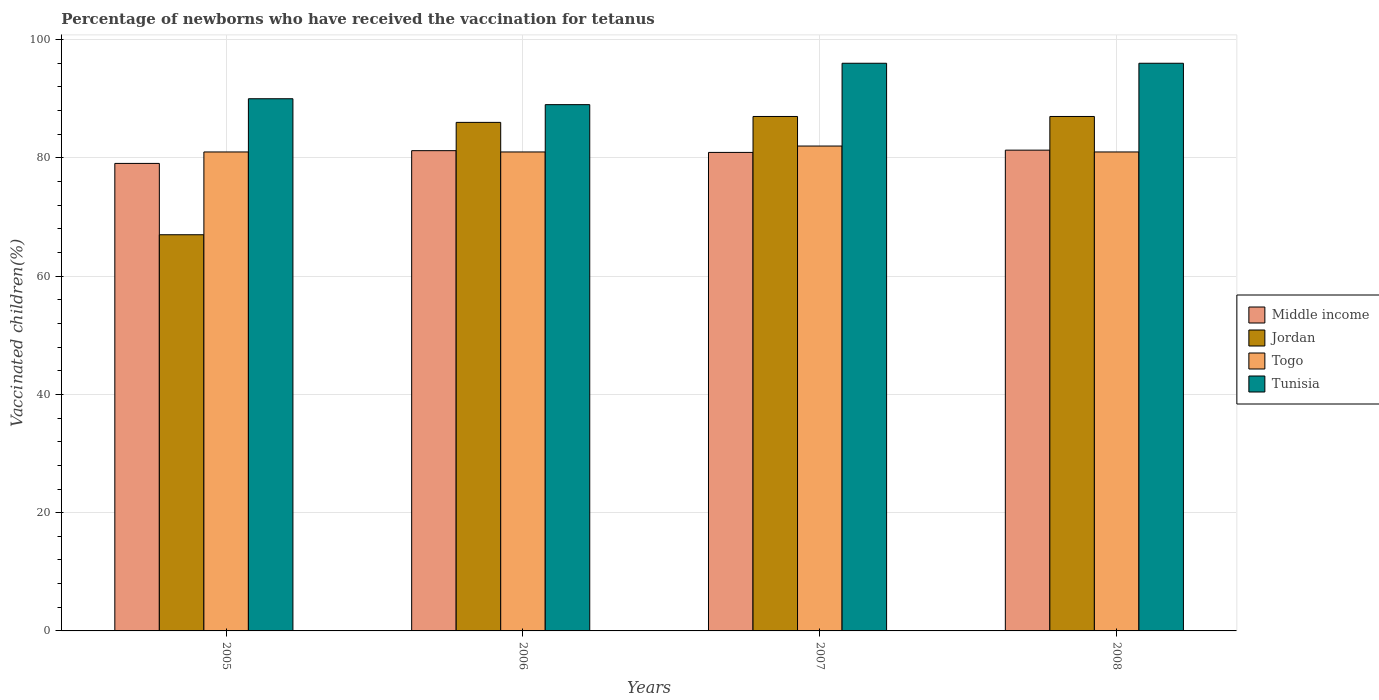How many bars are there on the 2nd tick from the left?
Provide a succinct answer. 4. How many bars are there on the 2nd tick from the right?
Offer a very short reply. 4. In how many cases, is the number of bars for a given year not equal to the number of legend labels?
Keep it short and to the point. 0. Across all years, what is the maximum percentage of vaccinated children in Jordan?
Your answer should be compact. 87. Across all years, what is the minimum percentage of vaccinated children in Togo?
Offer a very short reply. 81. In which year was the percentage of vaccinated children in Tunisia maximum?
Offer a very short reply. 2007. What is the total percentage of vaccinated children in Tunisia in the graph?
Keep it short and to the point. 371. What is the difference between the percentage of vaccinated children in Tunisia in 2008 and the percentage of vaccinated children in Middle income in 2007?
Offer a very short reply. 15.08. What is the average percentage of vaccinated children in Middle income per year?
Your answer should be very brief. 80.63. In the year 2005, what is the difference between the percentage of vaccinated children in Togo and percentage of vaccinated children in Tunisia?
Your response must be concise. -9. In how many years, is the percentage of vaccinated children in Jordan greater than 20 %?
Keep it short and to the point. 4. Is the percentage of vaccinated children in Jordan in 2006 less than that in 2008?
Provide a succinct answer. Yes. Is the difference between the percentage of vaccinated children in Togo in 2005 and 2007 greater than the difference between the percentage of vaccinated children in Tunisia in 2005 and 2007?
Offer a terse response. Yes. What is the difference between the highest and the second highest percentage of vaccinated children in Jordan?
Your answer should be compact. 0. What is the difference between the highest and the lowest percentage of vaccinated children in Middle income?
Your answer should be very brief. 2.24. What does the 2nd bar from the left in 2007 represents?
Provide a succinct answer. Jordan. Is it the case that in every year, the sum of the percentage of vaccinated children in Togo and percentage of vaccinated children in Middle income is greater than the percentage of vaccinated children in Tunisia?
Provide a short and direct response. Yes. Are all the bars in the graph horizontal?
Give a very brief answer. No. How many years are there in the graph?
Your answer should be very brief. 4. Does the graph contain any zero values?
Ensure brevity in your answer.  No. What is the title of the graph?
Your answer should be compact. Percentage of newborns who have received the vaccination for tetanus. What is the label or title of the Y-axis?
Your answer should be very brief. Vaccinated children(%). What is the Vaccinated children(%) in Middle income in 2005?
Your answer should be very brief. 79.06. What is the Vaccinated children(%) in Jordan in 2005?
Your answer should be very brief. 67. What is the Vaccinated children(%) of Middle income in 2006?
Your answer should be very brief. 81.22. What is the Vaccinated children(%) of Tunisia in 2006?
Give a very brief answer. 89. What is the Vaccinated children(%) in Middle income in 2007?
Your response must be concise. 80.92. What is the Vaccinated children(%) of Tunisia in 2007?
Offer a very short reply. 96. What is the Vaccinated children(%) of Middle income in 2008?
Give a very brief answer. 81.3. What is the Vaccinated children(%) in Jordan in 2008?
Keep it short and to the point. 87. What is the Vaccinated children(%) of Tunisia in 2008?
Keep it short and to the point. 96. Across all years, what is the maximum Vaccinated children(%) of Middle income?
Offer a terse response. 81.3. Across all years, what is the maximum Vaccinated children(%) of Tunisia?
Make the answer very short. 96. Across all years, what is the minimum Vaccinated children(%) in Middle income?
Provide a short and direct response. 79.06. Across all years, what is the minimum Vaccinated children(%) in Tunisia?
Your answer should be very brief. 89. What is the total Vaccinated children(%) in Middle income in the graph?
Ensure brevity in your answer.  322.51. What is the total Vaccinated children(%) of Jordan in the graph?
Provide a short and direct response. 327. What is the total Vaccinated children(%) of Togo in the graph?
Give a very brief answer. 325. What is the total Vaccinated children(%) in Tunisia in the graph?
Your answer should be compact. 371. What is the difference between the Vaccinated children(%) in Middle income in 2005 and that in 2006?
Your response must be concise. -2.16. What is the difference between the Vaccinated children(%) of Togo in 2005 and that in 2006?
Provide a succinct answer. 0. What is the difference between the Vaccinated children(%) of Middle income in 2005 and that in 2007?
Provide a succinct answer. -1.86. What is the difference between the Vaccinated children(%) in Togo in 2005 and that in 2007?
Ensure brevity in your answer.  -1. What is the difference between the Vaccinated children(%) in Middle income in 2005 and that in 2008?
Keep it short and to the point. -2.24. What is the difference between the Vaccinated children(%) of Jordan in 2005 and that in 2008?
Provide a short and direct response. -20. What is the difference between the Vaccinated children(%) in Togo in 2005 and that in 2008?
Provide a short and direct response. 0. What is the difference between the Vaccinated children(%) of Tunisia in 2005 and that in 2008?
Keep it short and to the point. -6. What is the difference between the Vaccinated children(%) in Middle income in 2006 and that in 2007?
Provide a succinct answer. 0.3. What is the difference between the Vaccinated children(%) in Tunisia in 2006 and that in 2007?
Make the answer very short. -7. What is the difference between the Vaccinated children(%) in Middle income in 2006 and that in 2008?
Give a very brief answer. -0.09. What is the difference between the Vaccinated children(%) in Togo in 2006 and that in 2008?
Your answer should be compact. 0. What is the difference between the Vaccinated children(%) in Middle income in 2007 and that in 2008?
Keep it short and to the point. -0.38. What is the difference between the Vaccinated children(%) of Tunisia in 2007 and that in 2008?
Ensure brevity in your answer.  0. What is the difference between the Vaccinated children(%) of Middle income in 2005 and the Vaccinated children(%) of Jordan in 2006?
Offer a terse response. -6.94. What is the difference between the Vaccinated children(%) of Middle income in 2005 and the Vaccinated children(%) of Togo in 2006?
Offer a terse response. -1.94. What is the difference between the Vaccinated children(%) in Middle income in 2005 and the Vaccinated children(%) in Tunisia in 2006?
Offer a terse response. -9.94. What is the difference between the Vaccinated children(%) in Jordan in 2005 and the Vaccinated children(%) in Togo in 2006?
Your answer should be compact. -14. What is the difference between the Vaccinated children(%) of Jordan in 2005 and the Vaccinated children(%) of Tunisia in 2006?
Give a very brief answer. -22. What is the difference between the Vaccinated children(%) of Middle income in 2005 and the Vaccinated children(%) of Jordan in 2007?
Offer a terse response. -7.94. What is the difference between the Vaccinated children(%) of Middle income in 2005 and the Vaccinated children(%) of Togo in 2007?
Your answer should be very brief. -2.94. What is the difference between the Vaccinated children(%) in Middle income in 2005 and the Vaccinated children(%) in Tunisia in 2007?
Make the answer very short. -16.94. What is the difference between the Vaccinated children(%) of Jordan in 2005 and the Vaccinated children(%) of Togo in 2007?
Offer a very short reply. -15. What is the difference between the Vaccinated children(%) in Middle income in 2005 and the Vaccinated children(%) in Jordan in 2008?
Make the answer very short. -7.94. What is the difference between the Vaccinated children(%) of Middle income in 2005 and the Vaccinated children(%) of Togo in 2008?
Offer a terse response. -1.94. What is the difference between the Vaccinated children(%) in Middle income in 2005 and the Vaccinated children(%) in Tunisia in 2008?
Your answer should be compact. -16.94. What is the difference between the Vaccinated children(%) in Jordan in 2005 and the Vaccinated children(%) in Tunisia in 2008?
Your response must be concise. -29. What is the difference between the Vaccinated children(%) in Togo in 2005 and the Vaccinated children(%) in Tunisia in 2008?
Give a very brief answer. -15. What is the difference between the Vaccinated children(%) of Middle income in 2006 and the Vaccinated children(%) of Jordan in 2007?
Offer a very short reply. -5.78. What is the difference between the Vaccinated children(%) of Middle income in 2006 and the Vaccinated children(%) of Togo in 2007?
Offer a very short reply. -0.78. What is the difference between the Vaccinated children(%) in Middle income in 2006 and the Vaccinated children(%) in Tunisia in 2007?
Your response must be concise. -14.78. What is the difference between the Vaccinated children(%) in Jordan in 2006 and the Vaccinated children(%) in Tunisia in 2007?
Ensure brevity in your answer.  -10. What is the difference between the Vaccinated children(%) in Middle income in 2006 and the Vaccinated children(%) in Jordan in 2008?
Ensure brevity in your answer.  -5.78. What is the difference between the Vaccinated children(%) of Middle income in 2006 and the Vaccinated children(%) of Togo in 2008?
Your response must be concise. 0.22. What is the difference between the Vaccinated children(%) in Middle income in 2006 and the Vaccinated children(%) in Tunisia in 2008?
Offer a very short reply. -14.78. What is the difference between the Vaccinated children(%) in Jordan in 2006 and the Vaccinated children(%) in Togo in 2008?
Keep it short and to the point. 5. What is the difference between the Vaccinated children(%) of Jordan in 2006 and the Vaccinated children(%) of Tunisia in 2008?
Your answer should be very brief. -10. What is the difference between the Vaccinated children(%) in Middle income in 2007 and the Vaccinated children(%) in Jordan in 2008?
Keep it short and to the point. -6.08. What is the difference between the Vaccinated children(%) in Middle income in 2007 and the Vaccinated children(%) in Togo in 2008?
Make the answer very short. -0.08. What is the difference between the Vaccinated children(%) in Middle income in 2007 and the Vaccinated children(%) in Tunisia in 2008?
Ensure brevity in your answer.  -15.08. What is the average Vaccinated children(%) in Middle income per year?
Provide a succinct answer. 80.63. What is the average Vaccinated children(%) of Jordan per year?
Give a very brief answer. 81.75. What is the average Vaccinated children(%) in Togo per year?
Provide a succinct answer. 81.25. What is the average Vaccinated children(%) of Tunisia per year?
Provide a short and direct response. 92.75. In the year 2005, what is the difference between the Vaccinated children(%) of Middle income and Vaccinated children(%) of Jordan?
Offer a terse response. 12.06. In the year 2005, what is the difference between the Vaccinated children(%) in Middle income and Vaccinated children(%) in Togo?
Ensure brevity in your answer.  -1.94. In the year 2005, what is the difference between the Vaccinated children(%) of Middle income and Vaccinated children(%) of Tunisia?
Give a very brief answer. -10.94. In the year 2005, what is the difference between the Vaccinated children(%) of Jordan and Vaccinated children(%) of Tunisia?
Offer a terse response. -23. In the year 2006, what is the difference between the Vaccinated children(%) of Middle income and Vaccinated children(%) of Jordan?
Offer a terse response. -4.78. In the year 2006, what is the difference between the Vaccinated children(%) in Middle income and Vaccinated children(%) in Togo?
Keep it short and to the point. 0.22. In the year 2006, what is the difference between the Vaccinated children(%) in Middle income and Vaccinated children(%) in Tunisia?
Provide a succinct answer. -7.78. In the year 2006, what is the difference between the Vaccinated children(%) in Jordan and Vaccinated children(%) in Togo?
Offer a terse response. 5. In the year 2006, what is the difference between the Vaccinated children(%) in Jordan and Vaccinated children(%) in Tunisia?
Offer a very short reply. -3. In the year 2007, what is the difference between the Vaccinated children(%) in Middle income and Vaccinated children(%) in Jordan?
Your answer should be very brief. -6.08. In the year 2007, what is the difference between the Vaccinated children(%) in Middle income and Vaccinated children(%) in Togo?
Keep it short and to the point. -1.08. In the year 2007, what is the difference between the Vaccinated children(%) in Middle income and Vaccinated children(%) in Tunisia?
Make the answer very short. -15.08. In the year 2008, what is the difference between the Vaccinated children(%) of Middle income and Vaccinated children(%) of Jordan?
Keep it short and to the point. -5.7. In the year 2008, what is the difference between the Vaccinated children(%) of Middle income and Vaccinated children(%) of Togo?
Make the answer very short. 0.3. In the year 2008, what is the difference between the Vaccinated children(%) of Middle income and Vaccinated children(%) of Tunisia?
Your response must be concise. -14.7. What is the ratio of the Vaccinated children(%) in Middle income in 2005 to that in 2006?
Keep it short and to the point. 0.97. What is the ratio of the Vaccinated children(%) of Jordan in 2005 to that in 2006?
Ensure brevity in your answer.  0.78. What is the ratio of the Vaccinated children(%) in Tunisia in 2005 to that in 2006?
Make the answer very short. 1.01. What is the ratio of the Vaccinated children(%) in Middle income in 2005 to that in 2007?
Provide a short and direct response. 0.98. What is the ratio of the Vaccinated children(%) of Jordan in 2005 to that in 2007?
Make the answer very short. 0.77. What is the ratio of the Vaccinated children(%) of Tunisia in 2005 to that in 2007?
Your answer should be very brief. 0.94. What is the ratio of the Vaccinated children(%) in Middle income in 2005 to that in 2008?
Your response must be concise. 0.97. What is the ratio of the Vaccinated children(%) of Jordan in 2005 to that in 2008?
Your answer should be very brief. 0.77. What is the ratio of the Vaccinated children(%) in Tunisia in 2006 to that in 2007?
Offer a terse response. 0.93. What is the ratio of the Vaccinated children(%) of Jordan in 2006 to that in 2008?
Provide a short and direct response. 0.99. What is the ratio of the Vaccinated children(%) in Togo in 2006 to that in 2008?
Keep it short and to the point. 1. What is the ratio of the Vaccinated children(%) of Tunisia in 2006 to that in 2008?
Make the answer very short. 0.93. What is the ratio of the Vaccinated children(%) in Jordan in 2007 to that in 2008?
Provide a short and direct response. 1. What is the ratio of the Vaccinated children(%) of Togo in 2007 to that in 2008?
Offer a very short reply. 1.01. What is the difference between the highest and the second highest Vaccinated children(%) of Middle income?
Your answer should be compact. 0.09. What is the difference between the highest and the second highest Vaccinated children(%) of Jordan?
Your answer should be compact. 0. What is the difference between the highest and the second highest Vaccinated children(%) in Togo?
Your response must be concise. 1. What is the difference between the highest and the second highest Vaccinated children(%) in Tunisia?
Offer a terse response. 0. What is the difference between the highest and the lowest Vaccinated children(%) in Middle income?
Offer a very short reply. 2.24. What is the difference between the highest and the lowest Vaccinated children(%) of Jordan?
Provide a succinct answer. 20. What is the difference between the highest and the lowest Vaccinated children(%) in Togo?
Offer a very short reply. 1. 